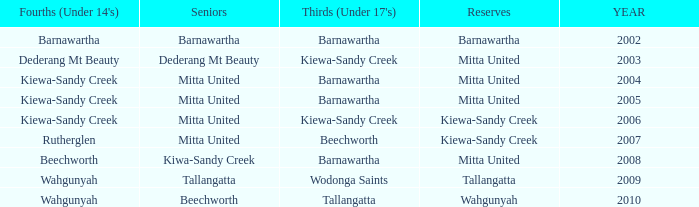Which seniors have a year before 2007, Fourths (Under 14's) of kiewa-sandy creek, and a Reserve of mitta united? Mitta United, Mitta United. 